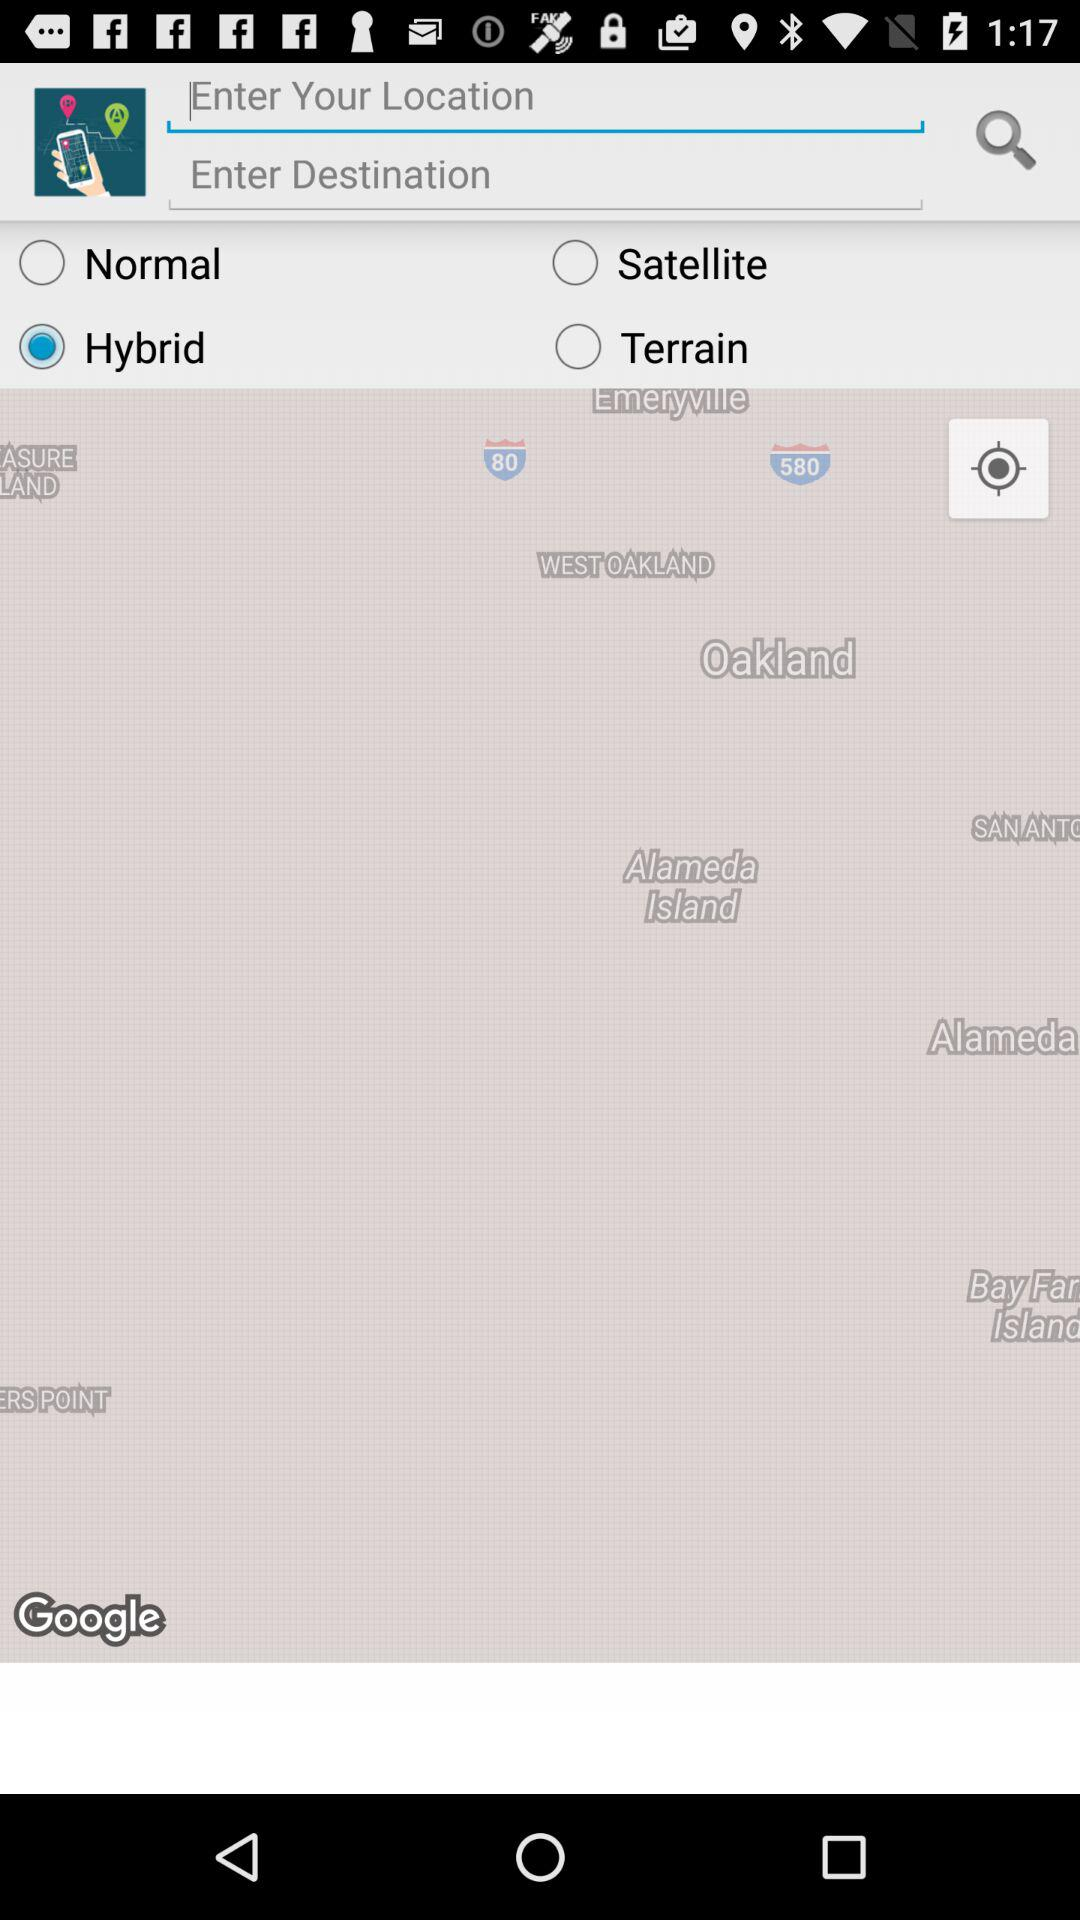Which option has been selected? The selected option is "Hybrid". 